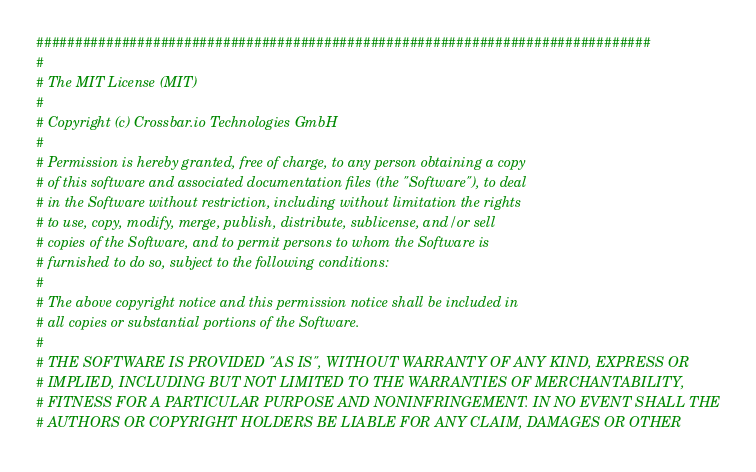Convert code to text. <code><loc_0><loc_0><loc_500><loc_500><_Python_>###############################################################################
#
# The MIT License (MIT)
#
# Copyright (c) Crossbar.io Technologies GmbH
#
# Permission is hereby granted, free of charge, to any person obtaining a copy
# of this software and associated documentation files (the "Software"), to deal
# in the Software without restriction, including without limitation the rights
# to use, copy, modify, merge, publish, distribute, sublicense, and/or sell
# copies of the Software, and to permit persons to whom the Software is
# furnished to do so, subject to the following conditions:
#
# The above copyright notice and this permission notice shall be included in
# all copies or substantial portions of the Software.
#
# THE SOFTWARE IS PROVIDED "AS IS", WITHOUT WARRANTY OF ANY KIND, EXPRESS OR
# IMPLIED, INCLUDING BUT NOT LIMITED TO THE WARRANTIES OF MERCHANTABILITY,
# FITNESS FOR A PARTICULAR PURPOSE AND NONINFRINGEMENT. IN NO EVENT SHALL THE
# AUTHORS OR COPYRIGHT HOLDERS BE LIABLE FOR ANY CLAIM, DAMAGES OR OTHER</code> 